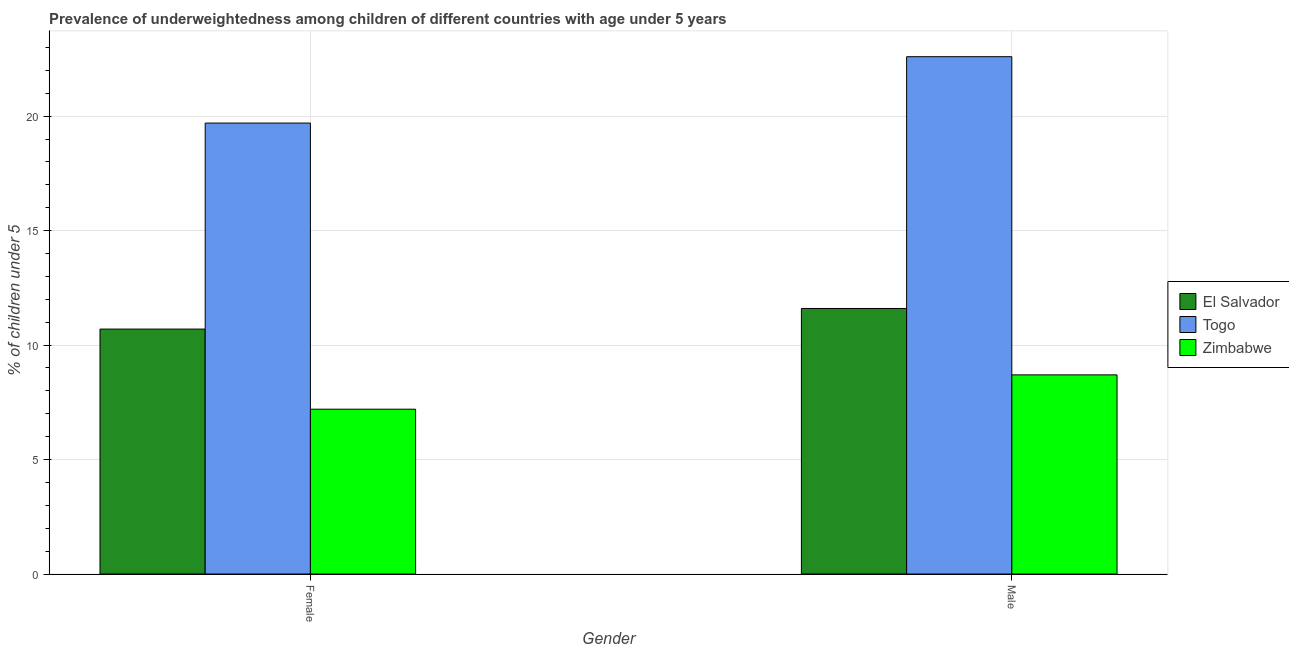How many different coloured bars are there?
Your answer should be very brief. 3. How many groups of bars are there?
Give a very brief answer. 2. What is the label of the 2nd group of bars from the left?
Your answer should be compact. Male. What is the percentage of underweighted female children in Zimbabwe?
Offer a terse response. 7.2. Across all countries, what is the maximum percentage of underweighted male children?
Make the answer very short. 22.6. Across all countries, what is the minimum percentage of underweighted male children?
Keep it short and to the point. 8.7. In which country was the percentage of underweighted female children maximum?
Ensure brevity in your answer.  Togo. In which country was the percentage of underweighted male children minimum?
Make the answer very short. Zimbabwe. What is the total percentage of underweighted male children in the graph?
Provide a succinct answer. 42.9. What is the difference between the percentage of underweighted female children in Togo and that in El Salvador?
Your answer should be very brief. 9. What is the difference between the percentage of underweighted male children in Togo and the percentage of underweighted female children in Zimbabwe?
Keep it short and to the point. 15.4. What is the average percentage of underweighted female children per country?
Provide a succinct answer. 12.53. What is the difference between the percentage of underweighted male children and percentage of underweighted female children in Togo?
Provide a succinct answer. 2.9. What is the ratio of the percentage of underweighted male children in Zimbabwe to that in El Salvador?
Your answer should be very brief. 0.75. What does the 3rd bar from the left in Male represents?
Your response must be concise. Zimbabwe. What does the 1st bar from the right in Female represents?
Your answer should be very brief. Zimbabwe. Are all the bars in the graph horizontal?
Your answer should be compact. No. How many countries are there in the graph?
Your response must be concise. 3. Are the values on the major ticks of Y-axis written in scientific E-notation?
Provide a succinct answer. No. Does the graph contain grids?
Your answer should be very brief. Yes. What is the title of the graph?
Keep it short and to the point. Prevalence of underweightedness among children of different countries with age under 5 years. What is the label or title of the Y-axis?
Give a very brief answer.  % of children under 5. What is the  % of children under 5 in El Salvador in Female?
Your response must be concise. 10.7. What is the  % of children under 5 in Togo in Female?
Your response must be concise. 19.7. What is the  % of children under 5 in Zimbabwe in Female?
Provide a succinct answer. 7.2. What is the  % of children under 5 of El Salvador in Male?
Keep it short and to the point. 11.6. What is the  % of children under 5 of Togo in Male?
Give a very brief answer. 22.6. What is the  % of children under 5 in Zimbabwe in Male?
Your answer should be very brief. 8.7. Across all Gender, what is the maximum  % of children under 5 of El Salvador?
Provide a short and direct response. 11.6. Across all Gender, what is the maximum  % of children under 5 in Togo?
Provide a short and direct response. 22.6. Across all Gender, what is the maximum  % of children under 5 in Zimbabwe?
Provide a succinct answer. 8.7. Across all Gender, what is the minimum  % of children under 5 in El Salvador?
Your answer should be very brief. 10.7. Across all Gender, what is the minimum  % of children under 5 of Togo?
Your answer should be compact. 19.7. Across all Gender, what is the minimum  % of children under 5 of Zimbabwe?
Offer a terse response. 7.2. What is the total  % of children under 5 in El Salvador in the graph?
Give a very brief answer. 22.3. What is the total  % of children under 5 of Togo in the graph?
Your answer should be compact. 42.3. What is the difference between the  % of children under 5 of El Salvador in Female and the  % of children under 5 of Togo in Male?
Offer a terse response. -11.9. What is the difference between the  % of children under 5 of El Salvador in Female and the  % of children under 5 of Zimbabwe in Male?
Provide a succinct answer. 2. What is the average  % of children under 5 in El Salvador per Gender?
Offer a very short reply. 11.15. What is the average  % of children under 5 of Togo per Gender?
Provide a succinct answer. 21.15. What is the average  % of children under 5 in Zimbabwe per Gender?
Make the answer very short. 7.95. What is the difference between the  % of children under 5 in El Salvador and  % of children under 5 in Togo in Female?
Provide a short and direct response. -9. What is the difference between the  % of children under 5 in El Salvador and  % of children under 5 in Zimbabwe in Female?
Your response must be concise. 3.5. What is the difference between the  % of children under 5 of Togo and  % of children under 5 of Zimbabwe in Female?
Provide a short and direct response. 12.5. What is the difference between the  % of children under 5 in El Salvador and  % of children under 5 in Zimbabwe in Male?
Ensure brevity in your answer.  2.9. What is the difference between the  % of children under 5 of Togo and  % of children under 5 of Zimbabwe in Male?
Offer a very short reply. 13.9. What is the ratio of the  % of children under 5 of El Salvador in Female to that in Male?
Make the answer very short. 0.92. What is the ratio of the  % of children under 5 of Togo in Female to that in Male?
Ensure brevity in your answer.  0.87. What is the ratio of the  % of children under 5 of Zimbabwe in Female to that in Male?
Your answer should be compact. 0.83. What is the difference between the highest and the second highest  % of children under 5 of Togo?
Ensure brevity in your answer.  2.9. What is the difference between the highest and the second highest  % of children under 5 of Zimbabwe?
Ensure brevity in your answer.  1.5. What is the difference between the highest and the lowest  % of children under 5 of El Salvador?
Your response must be concise. 0.9. What is the difference between the highest and the lowest  % of children under 5 of Togo?
Ensure brevity in your answer.  2.9. What is the difference between the highest and the lowest  % of children under 5 of Zimbabwe?
Give a very brief answer. 1.5. 